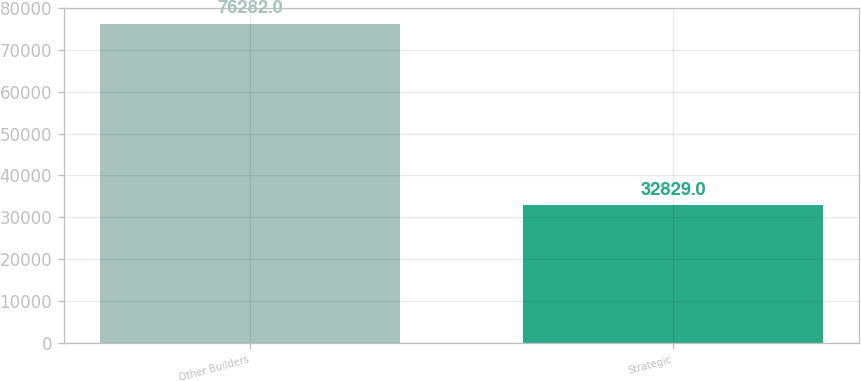Convert chart to OTSL. <chart><loc_0><loc_0><loc_500><loc_500><bar_chart><fcel>Other Builders<fcel>Strategic<nl><fcel>76282<fcel>32829<nl></chart> 